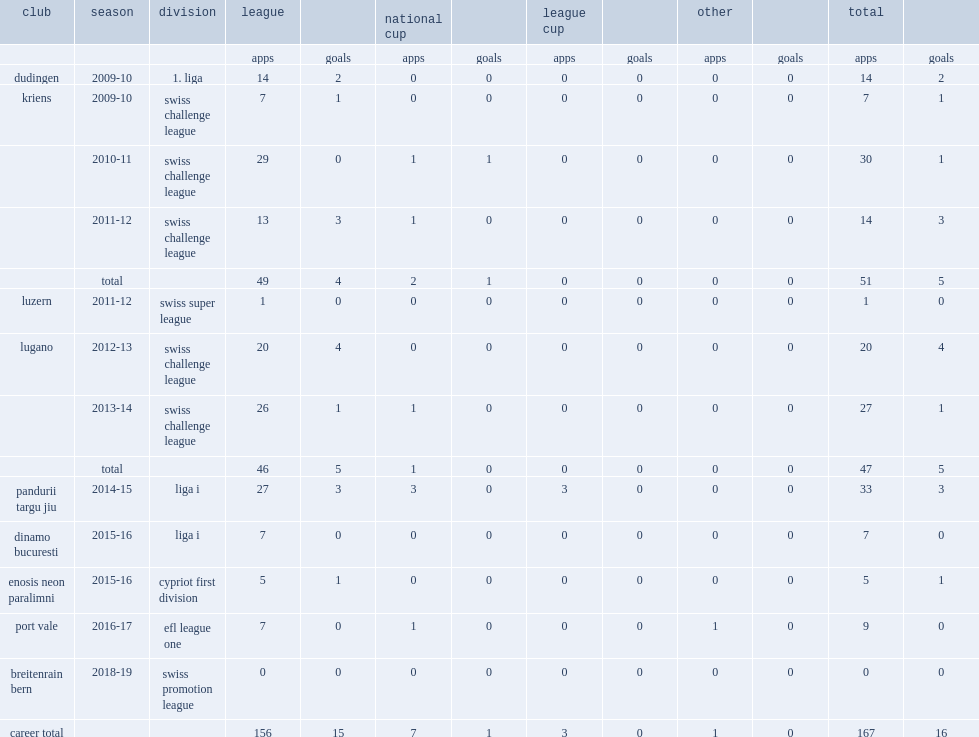Which club did gezim shalaj play for in 2014-15? Pandurii targu jiu. 